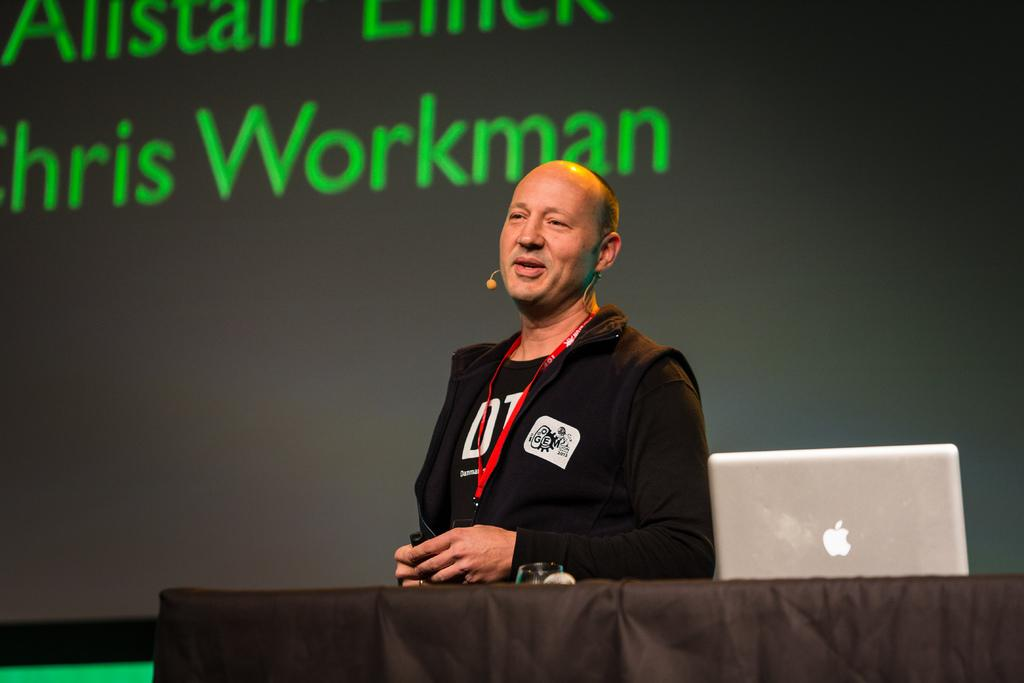<image>
Summarize the visual content of the image. A man giving a speech is wearing a jacket with GEM on it 